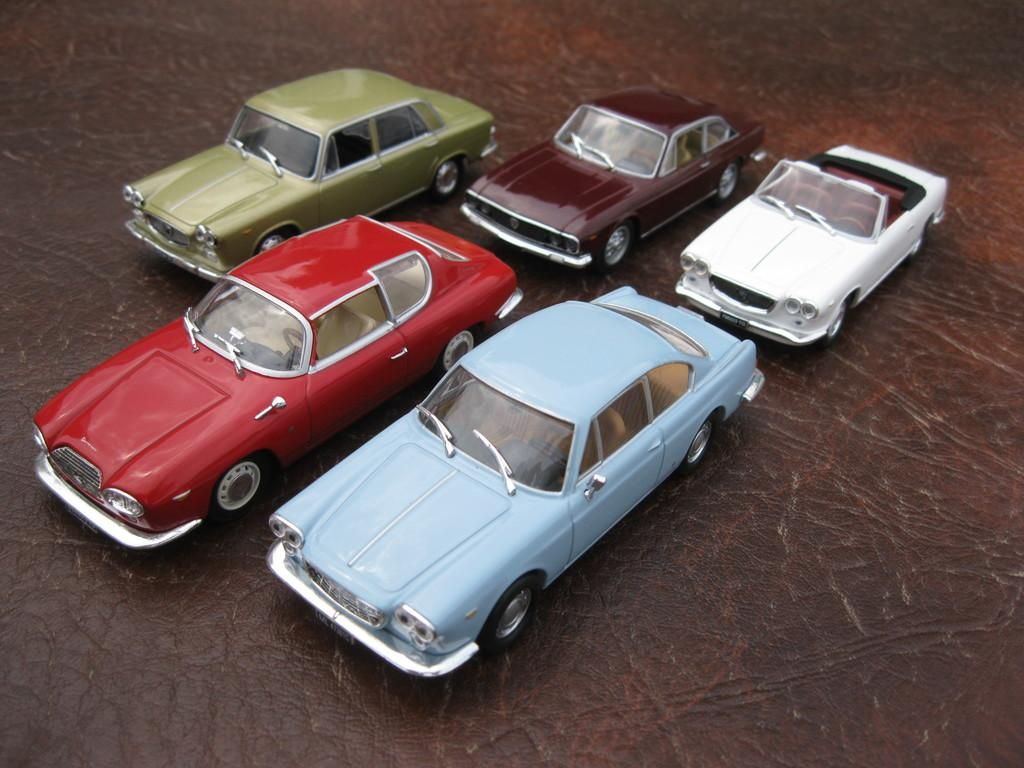How many cars are visible in the image? There are five cars in the image. Where are the cars located in the image? The cars are on the ground in the image. What type of beast can be seen reading books in the image? There is no beast or books present in the image; it only features five cars on the ground. 